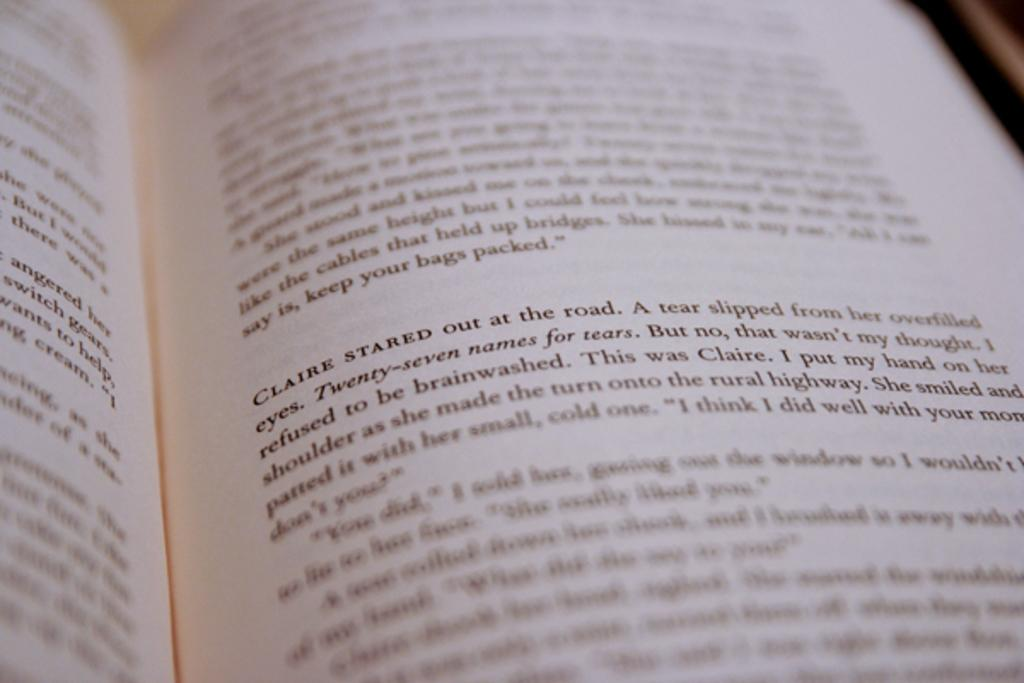<image>
Summarize the visual content of the image. A book that is focused on the paragraph where Claire stared out at the road. 